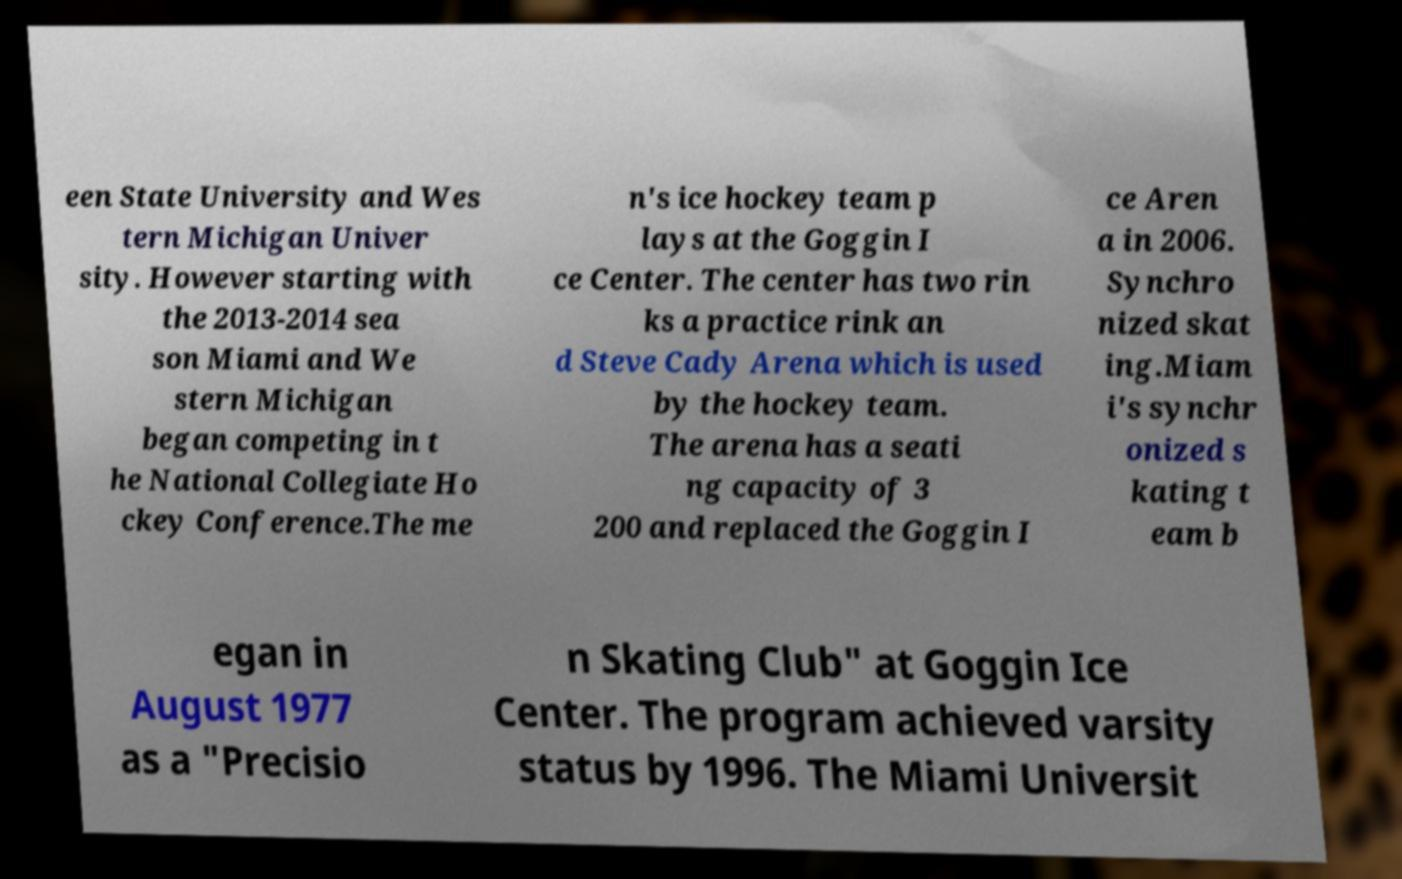Can you read and provide the text displayed in the image?This photo seems to have some interesting text. Can you extract and type it out for me? een State University and Wes tern Michigan Univer sity. However starting with the 2013-2014 sea son Miami and We stern Michigan began competing in t he National Collegiate Ho ckey Conference.The me n's ice hockey team p lays at the Goggin I ce Center. The center has two rin ks a practice rink an d Steve Cady Arena which is used by the hockey team. The arena has a seati ng capacity of 3 200 and replaced the Goggin I ce Aren a in 2006. Synchro nized skat ing.Miam i's synchr onized s kating t eam b egan in August 1977 as a "Precisio n Skating Club" at Goggin Ice Center. The program achieved varsity status by 1996. The Miami Universit 